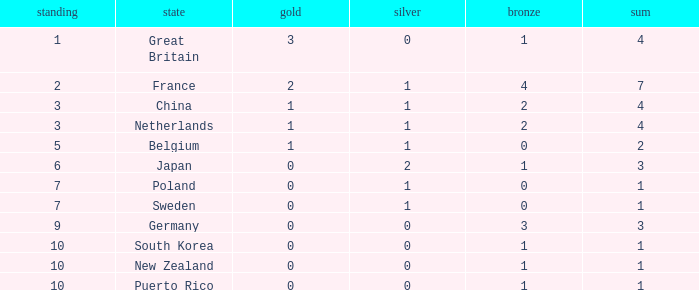What is the total where the gold is larger than 2? 1.0. 